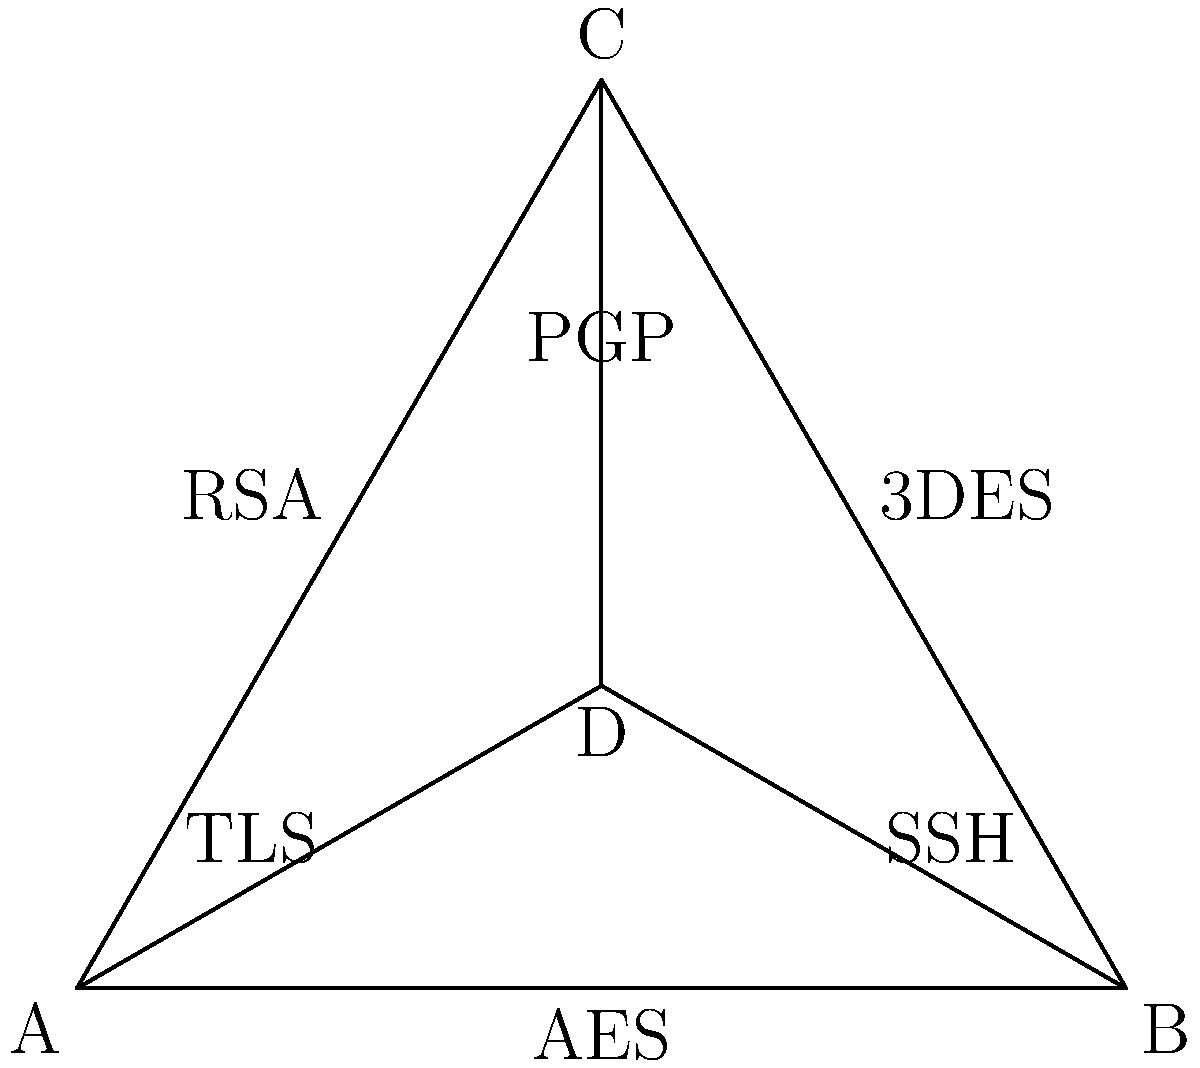In the given network topology diagram, which node would be the most secure central point for communication if you wanted to ensure end-to-end encryption between all connected devices? To determine the most secure central point for communication, we need to analyze the encryption methods used between each node:

1. Edge A-B uses AES (Advanced Encryption Standard), which is symmetric encryption.
2. Edge A-C uses RSA, which is asymmetric encryption.
3. Edge B-C uses 3DES (Triple Data Encryption Standard), which is symmetric encryption.
4. Edge A-D uses TLS (Transport Layer Security), which provides end-to-end encryption.
5. Edge B-D uses SSH (Secure Shell), which also provides end-to-end encryption.
6. Edge C-D uses PGP (Pretty Good Privacy), which offers end-to-end encryption.

Node D is connected to all other nodes (A, B, and C) using protocols that provide end-to-end encryption:
- TLS with node A
- SSH with node B
- PGP with node C

These protocols ensure that data is encrypted from the source to the destination, making node D the most secure central point for communication. It can securely communicate with all other nodes using strong encryption methods that protect the data throughout its entire journey.

In contrast, the other nodes have at least one connection that uses symmetric encryption (AES or 3DES), which, while strong, doesn't provide the same level of end-to-end security as TLS, SSH, or PGP.
Answer: Node D 